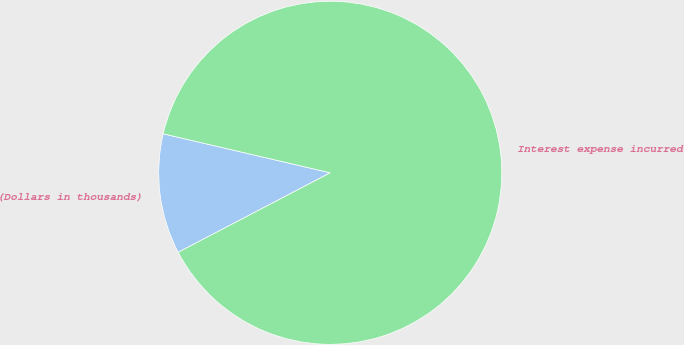Convert chart. <chart><loc_0><loc_0><loc_500><loc_500><pie_chart><fcel>(Dollars in thousands)<fcel>Interest expense incurred<nl><fcel>11.32%<fcel>88.68%<nl></chart> 